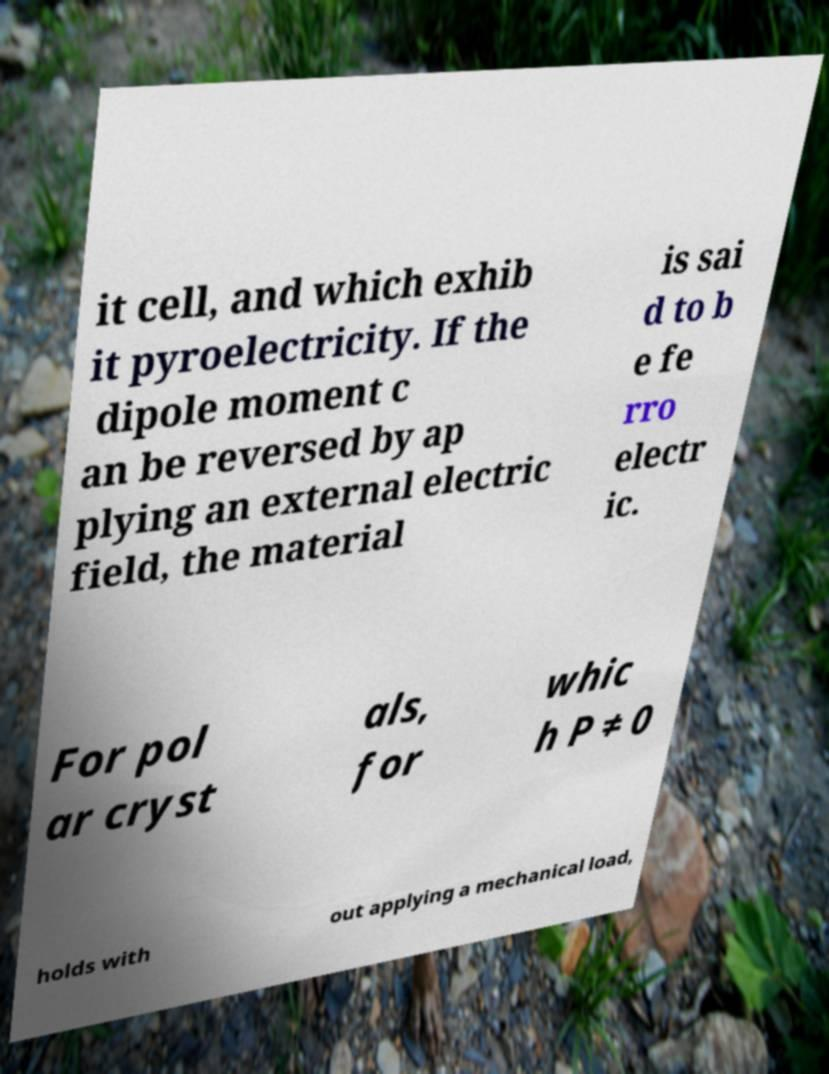Please read and relay the text visible in this image. What does it say? it cell, and which exhib it pyroelectricity. If the dipole moment c an be reversed by ap plying an external electric field, the material is sai d to b e fe rro electr ic. For pol ar cryst als, for whic h P ≠ 0 holds with out applying a mechanical load, 